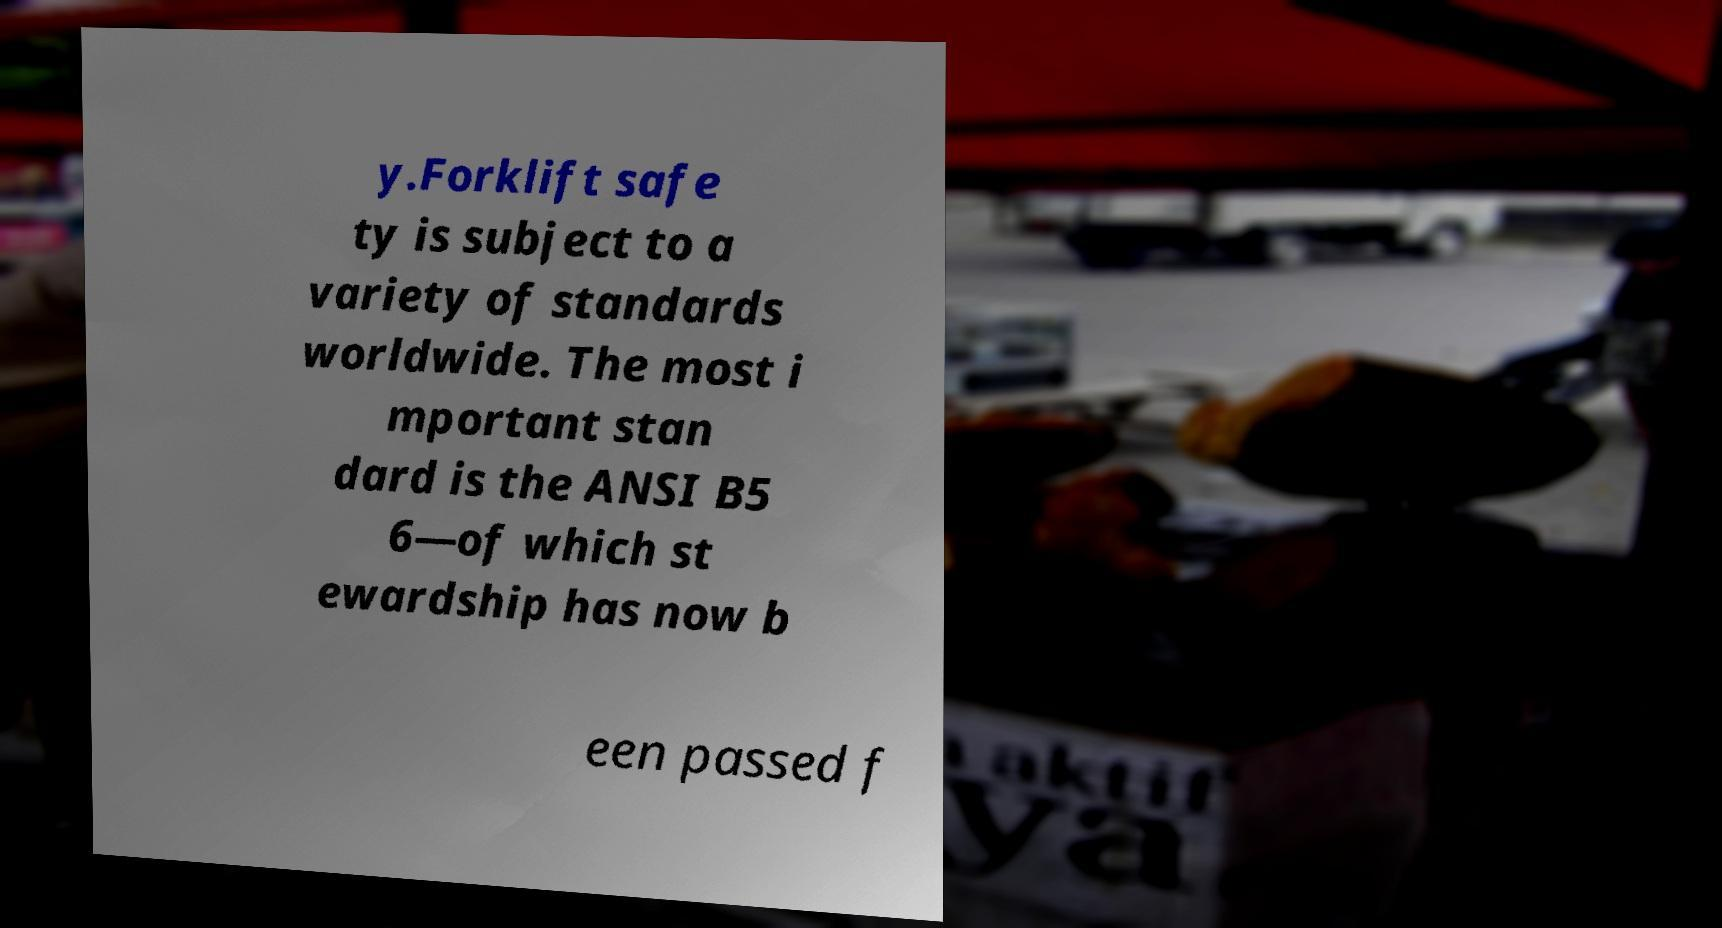Please read and relay the text visible in this image. What does it say? y.Forklift safe ty is subject to a variety of standards worldwide. The most i mportant stan dard is the ANSI B5 6—of which st ewardship has now b een passed f 